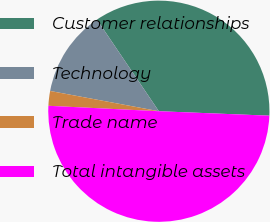<chart> <loc_0><loc_0><loc_500><loc_500><pie_chart><fcel>Customer relationships<fcel>Technology<fcel>Trade name<fcel>Total intangible assets<nl><fcel>35.1%<fcel>12.61%<fcel>2.15%<fcel>50.14%<nl></chart> 